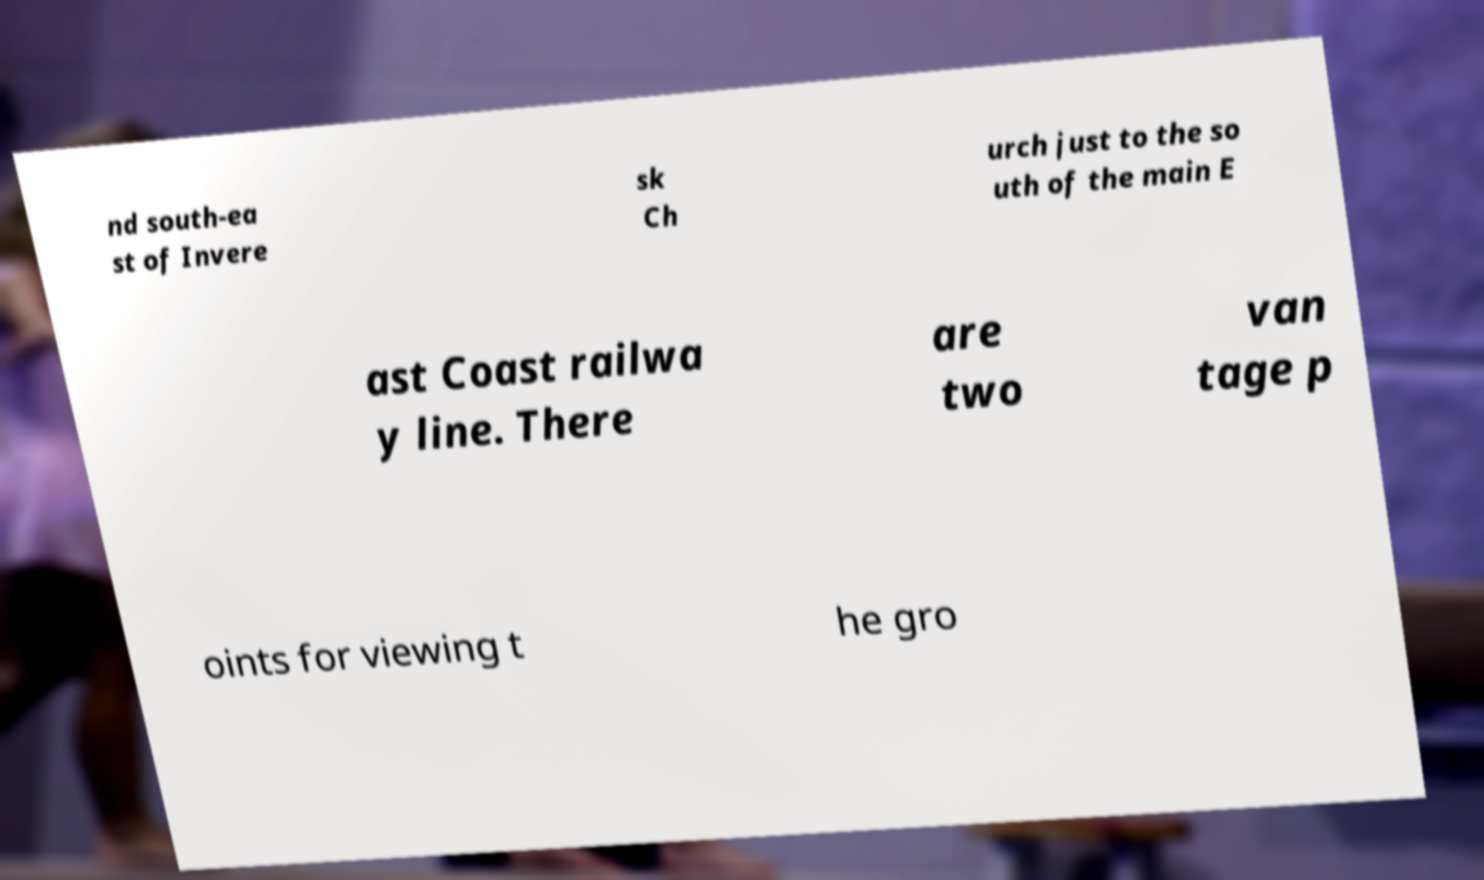Can you read and provide the text displayed in the image?This photo seems to have some interesting text. Can you extract and type it out for me? nd south-ea st of Invere sk Ch urch just to the so uth of the main E ast Coast railwa y line. There are two van tage p oints for viewing t he gro 